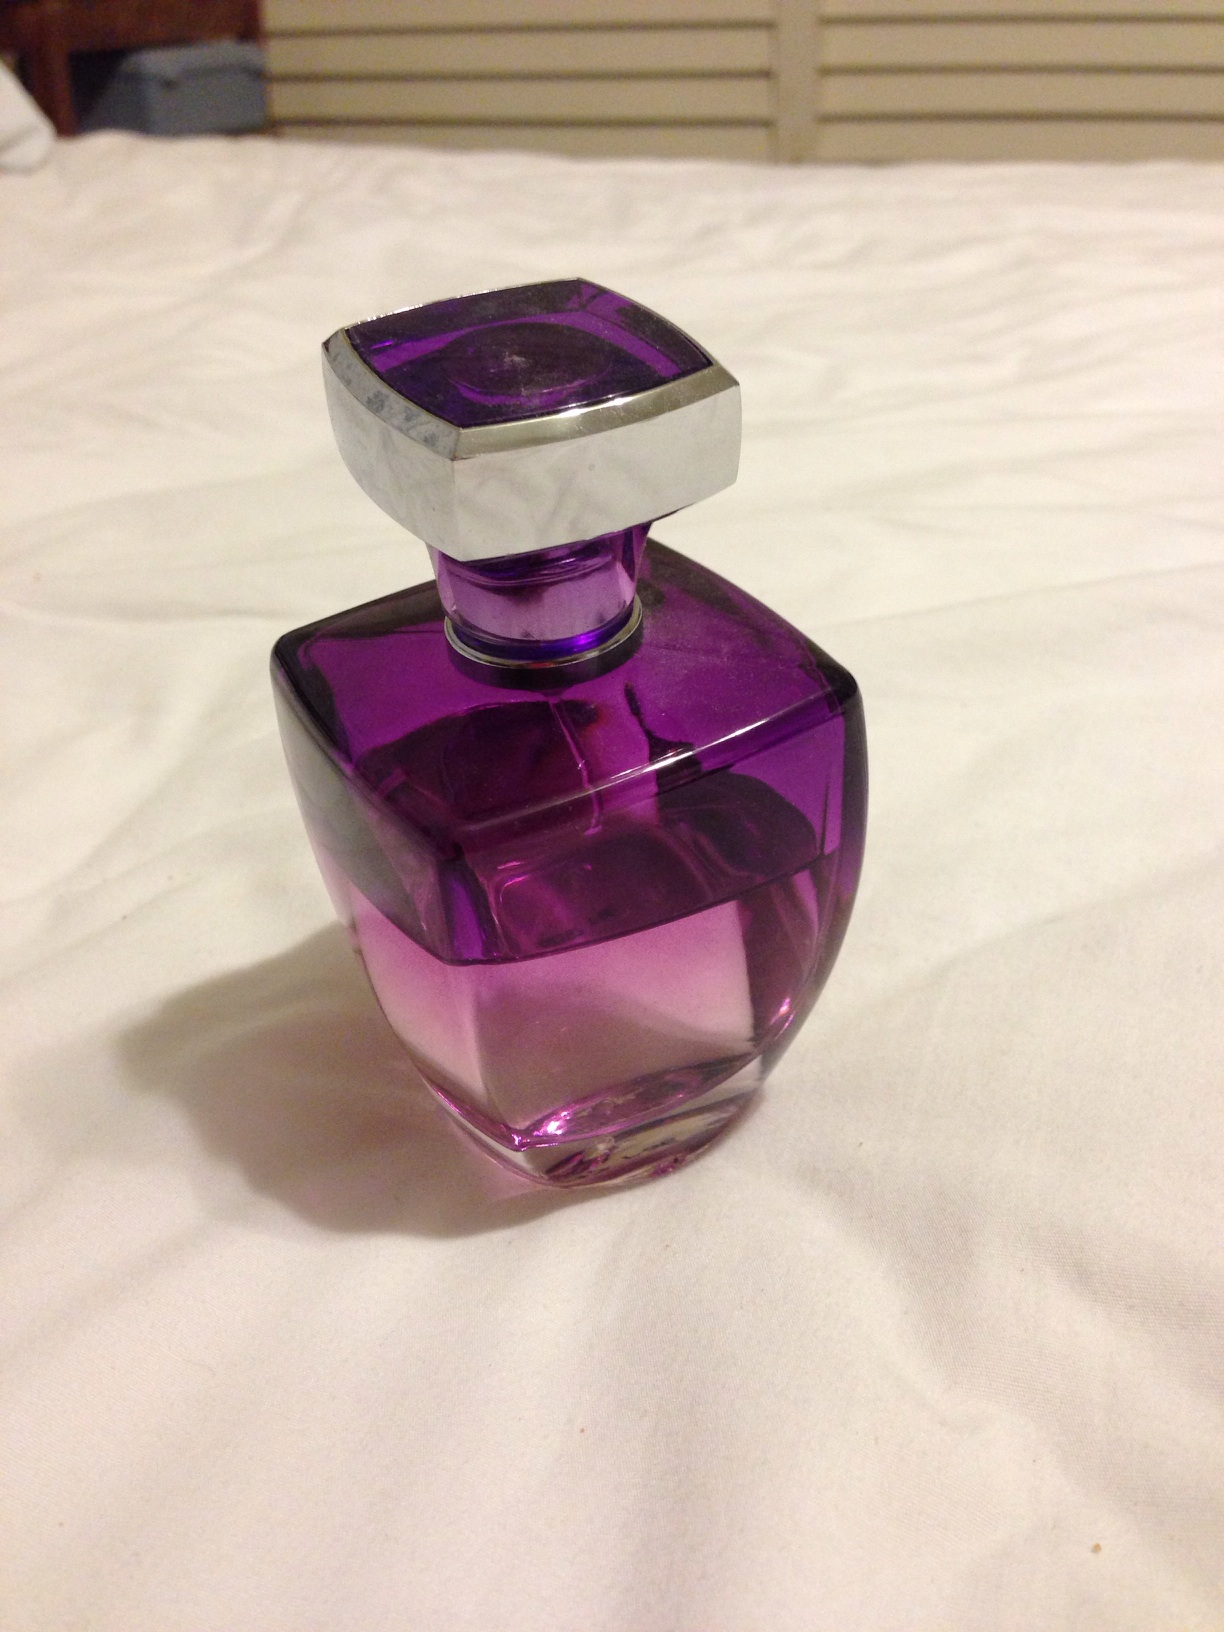What does the choice of color tell us about the perfume? The use of purple in the perfume bottle suggests a sense of mystery and depth. Purple is often associated with royalty, luxury, and creativity. This indicates that the perfume could have a rich, alluring scent, aimed at someone who wishes to stand out and express individuality. 